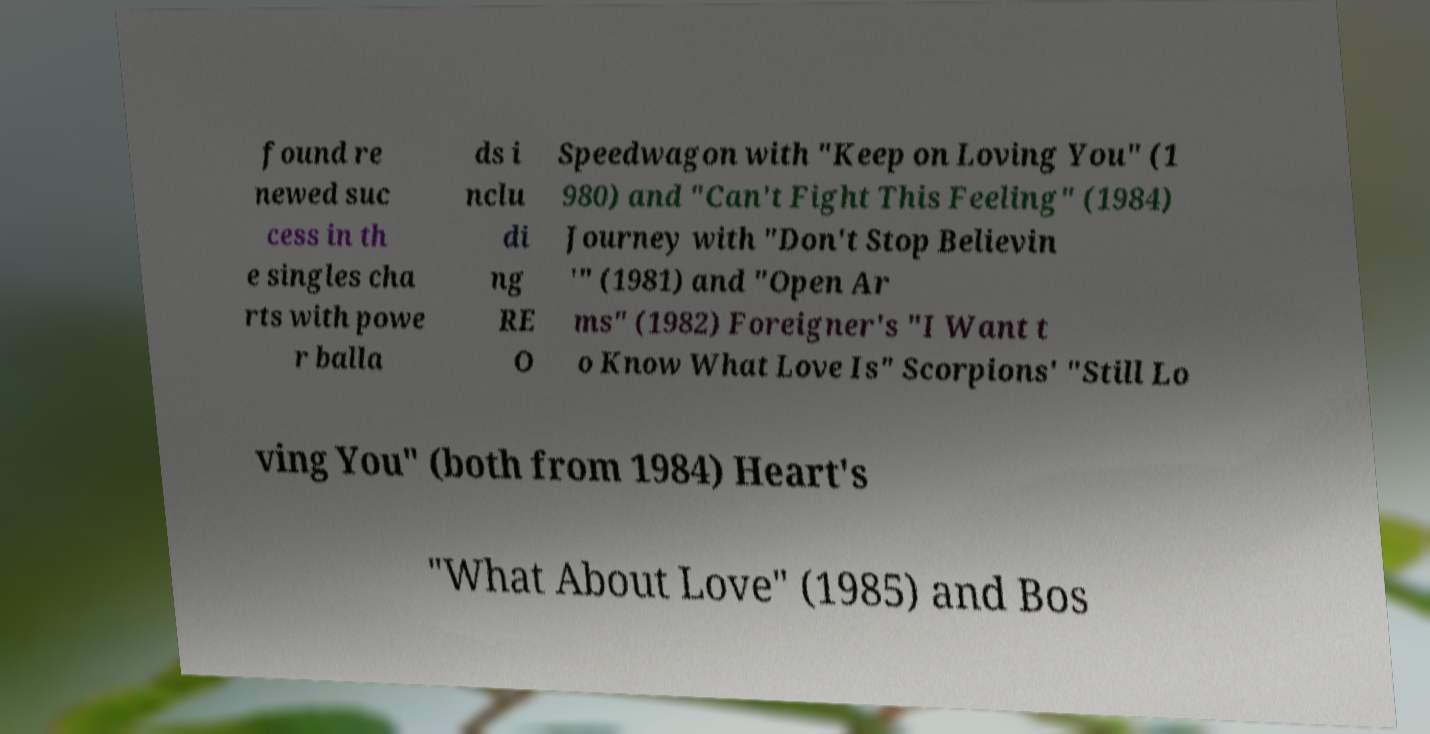Please identify and transcribe the text found in this image. found re newed suc cess in th e singles cha rts with powe r balla ds i nclu di ng RE O Speedwagon with "Keep on Loving You" (1 980) and "Can't Fight This Feeling" (1984) Journey with "Don't Stop Believin '" (1981) and "Open Ar ms" (1982) Foreigner's "I Want t o Know What Love Is" Scorpions' "Still Lo ving You" (both from 1984) Heart's "What About Love" (1985) and Bos 